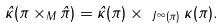Convert formula to latex. <formula><loc_0><loc_0><loc_500><loc_500>\hat { \kappa } ( \pi \times _ { M } \hat { \pi } ) = \hat { \kappa } ( \pi ) \times _ { \ J ^ { \infty } ( \pi ) } \kappa ( \pi ) .</formula> 